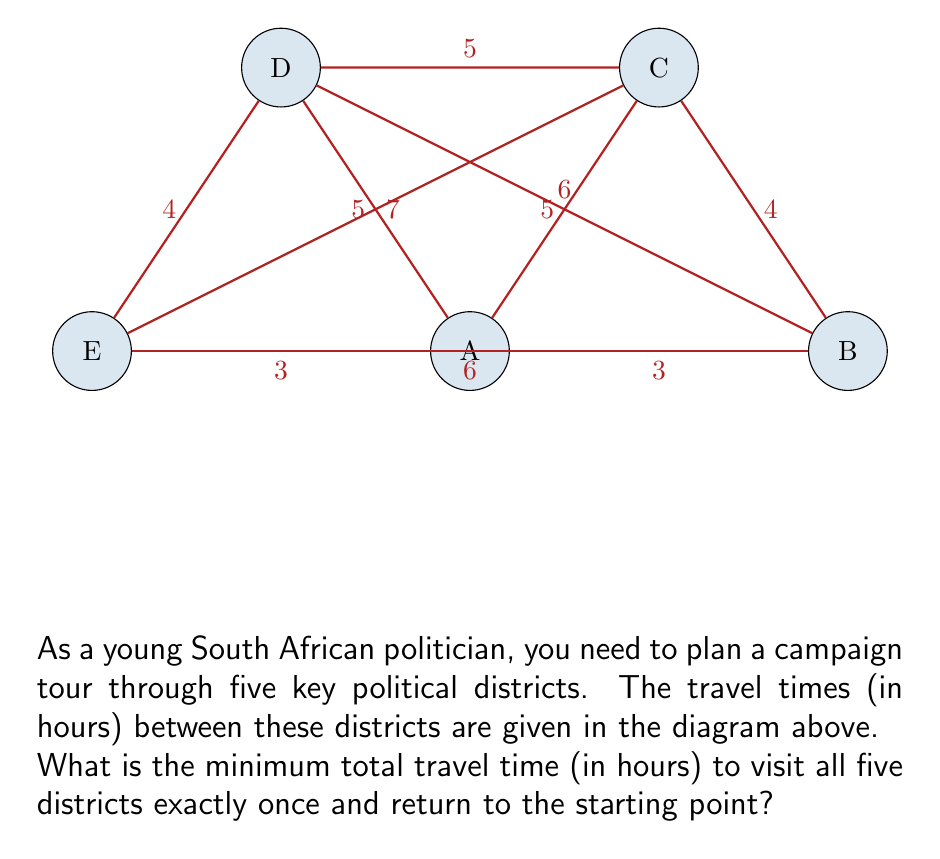Can you solve this math problem? To solve this problem, we need to find the shortest Hamiltonian cycle in the given graph, which is known as the Traveling Salesman Problem (TSP). While TSP is NP-hard for large graphs, we can solve this small instance by systematically checking all possible routes.

1) First, let's list all possible routes:
   There are $(5-1)! = 24$ possible routes, as we can fix the starting point and permute the rest.

2) Calculate the total time for each route. For example:
   A-B-C-D-E-A: $3 + 4 + 5 + 4 + 3 = 19$ hours
   A-B-C-E-D-A: $3 + 4 + 7 + 4 + 5 = 23$ hours
   ...

3) After calculating all routes, we find that the minimum time is achieved by the route:
   A-E-D-C-B-A: $3 + 4 + 5 + 4 + 3 = 19$ hours

4) We can verify that no other route gives a shorter total time.

Therefore, the minimum total travel time to visit all five districts once and return to the starting point is 19 hours.

This solution demonstrates the importance of efficient routing in political campaigns, allowing the politician to maximize face time with constituents while minimizing travel time.
Answer: 19 hours 